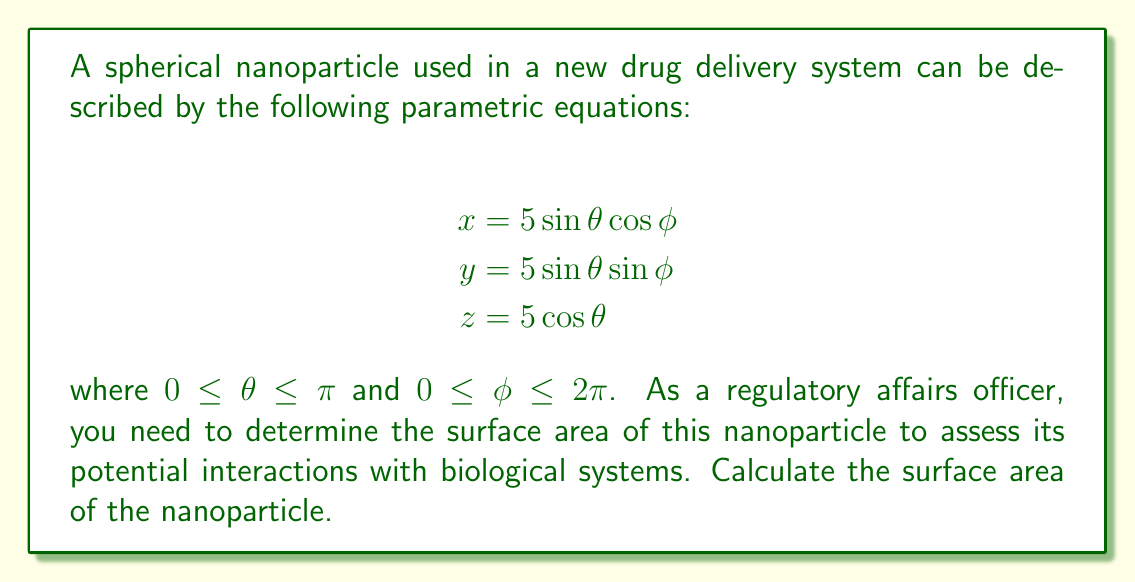What is the answer to this math problem? To determine the surface area of the nanoparticle, we'll follow these steps:

1) The surface area of a parametric surface is given by the formula:

   $$A = \int_a^b \int_c^d \sqrt{EG - F^2} \, d\theta \, d\phi$$

   where $E$, $F$, and $G$ are coefficients of the first fundamental form.

2) Calculate the partial derivatives:
   $$\frac{\partial x}{\partial \theta} = 5 \cos\theta \cos\phi$$
   $$\frac{\partial x}{\partial \phi} = -5 \sin\theta \sin\phi$$
   $$\frac{\partial y}{\partial \theta} = 5 \cos\theta \sin\phi$$
   $$\frac{\partial y}{\partial \phi} = 5 \sin\theta \cos\phi$$
   $$\frac{\partial z}{\partial \theta} = -5 \sin\theta$$
   $$\frac{\partial z}{\partial \phi} = 0$$

3) Calculate $E$, $F$, and $G$:
   $$E = (\frac{\partial x}{\partial \theta})^2 + (\frac{\partial y}{\partial \theta})^2 + (\frac{\partial z}{\partial \theta})^2 = 25$$
   $$F = \frac{\partial x}{\partial \theta}\frac{\partial x}{\partial \phi} + \frac{\partial y}{\partial \theta}\frac{\partial y}{\partial \phi} + \frac{\partial z}{\partial \theta}\frac{\partial z}{\partial \phi} = 0$$
   $$G = (\frac{\partial x}{\partial \phi})^2 + (\frac{\partial y}{\partial \phi})^2 + (\frac{\partial z}{\partial \phi})^2 = 25\sin^2\theta$$

4) Calculate $EG - F^2$:
   $$EG - F^2 = 25 \cdot 25\sin^2\theta - 0^2 = 625\sin^2\theta$$

5) Substitute into the surface area formula:
   $$A = \int_0^\pi \int_0^{2\pi} \sqrt{625\sin^2\theta} \, d\phi \, d\theta$$
   $$A = \int_0^\pi \int_0^{2\pi} 25|\sin\theta| \, d\phi \, d\theta$$

6) Integrate:
   $$A = 25 \int_0^\pi |\sin\theta| \int_0^{2\pi} \, d\phi \, d\theta$$
   $$A = 25 \cdot 2\pi \int_0^\pi |\sin\theta| \, d\theta$$
   $$A = 50\pi \cdot 2 = 100\pi$$

Therefore, the surface area of the nanoparticle is $100\pi$ square units.
Answer: The surface area of the nanoparticle is $100\pi$ square nanometers. 